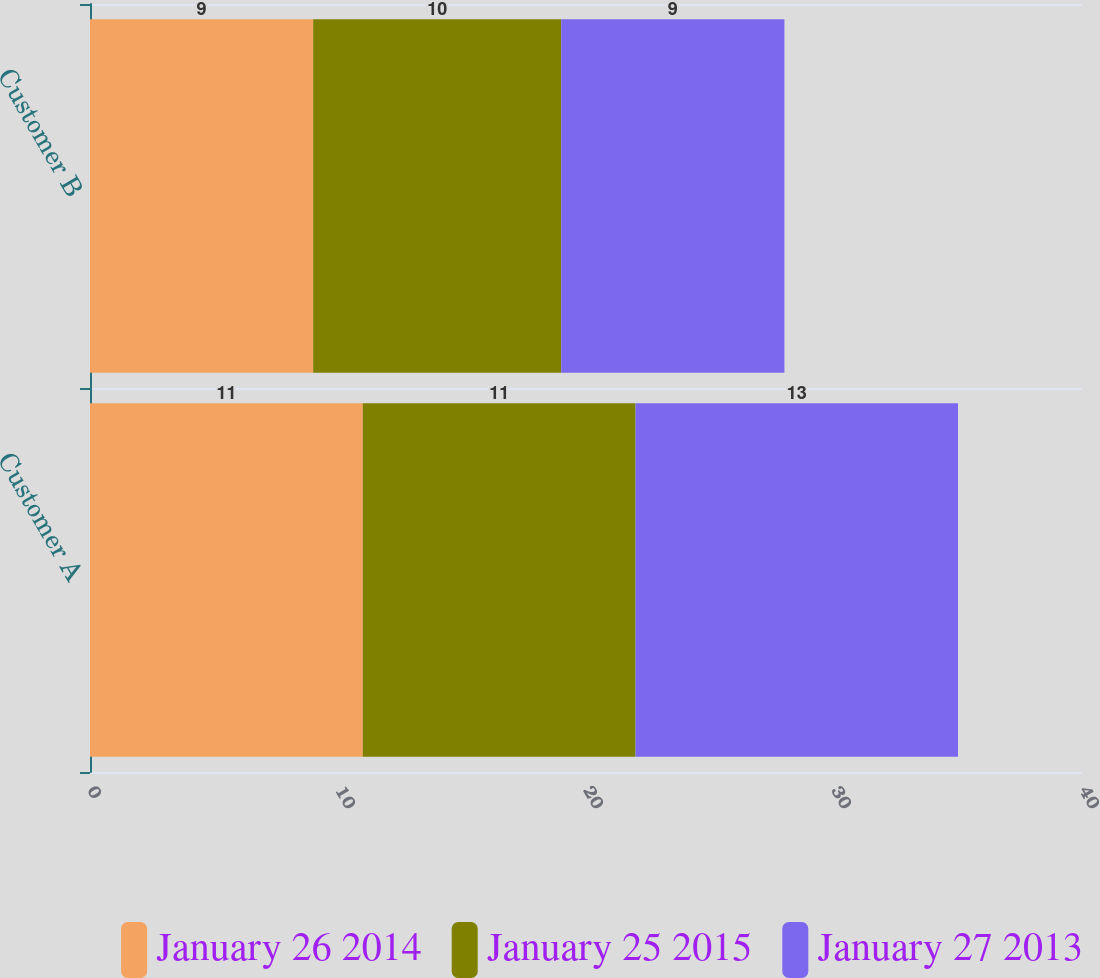Convert chart to OTSL. <chart><loc_0><loc_0><loc_500><loc_500><stacked_bar_chart><ecel><fcel>Customer A<fcel>Customer B<nl><fcel>January 26 2014<fcel>11<fcel>9<nl><fcel>January 25 2015<fcel>11<fcel>10<nl><fcel>January 27 2013<fcel>13<fcel>9<nl></chart> 